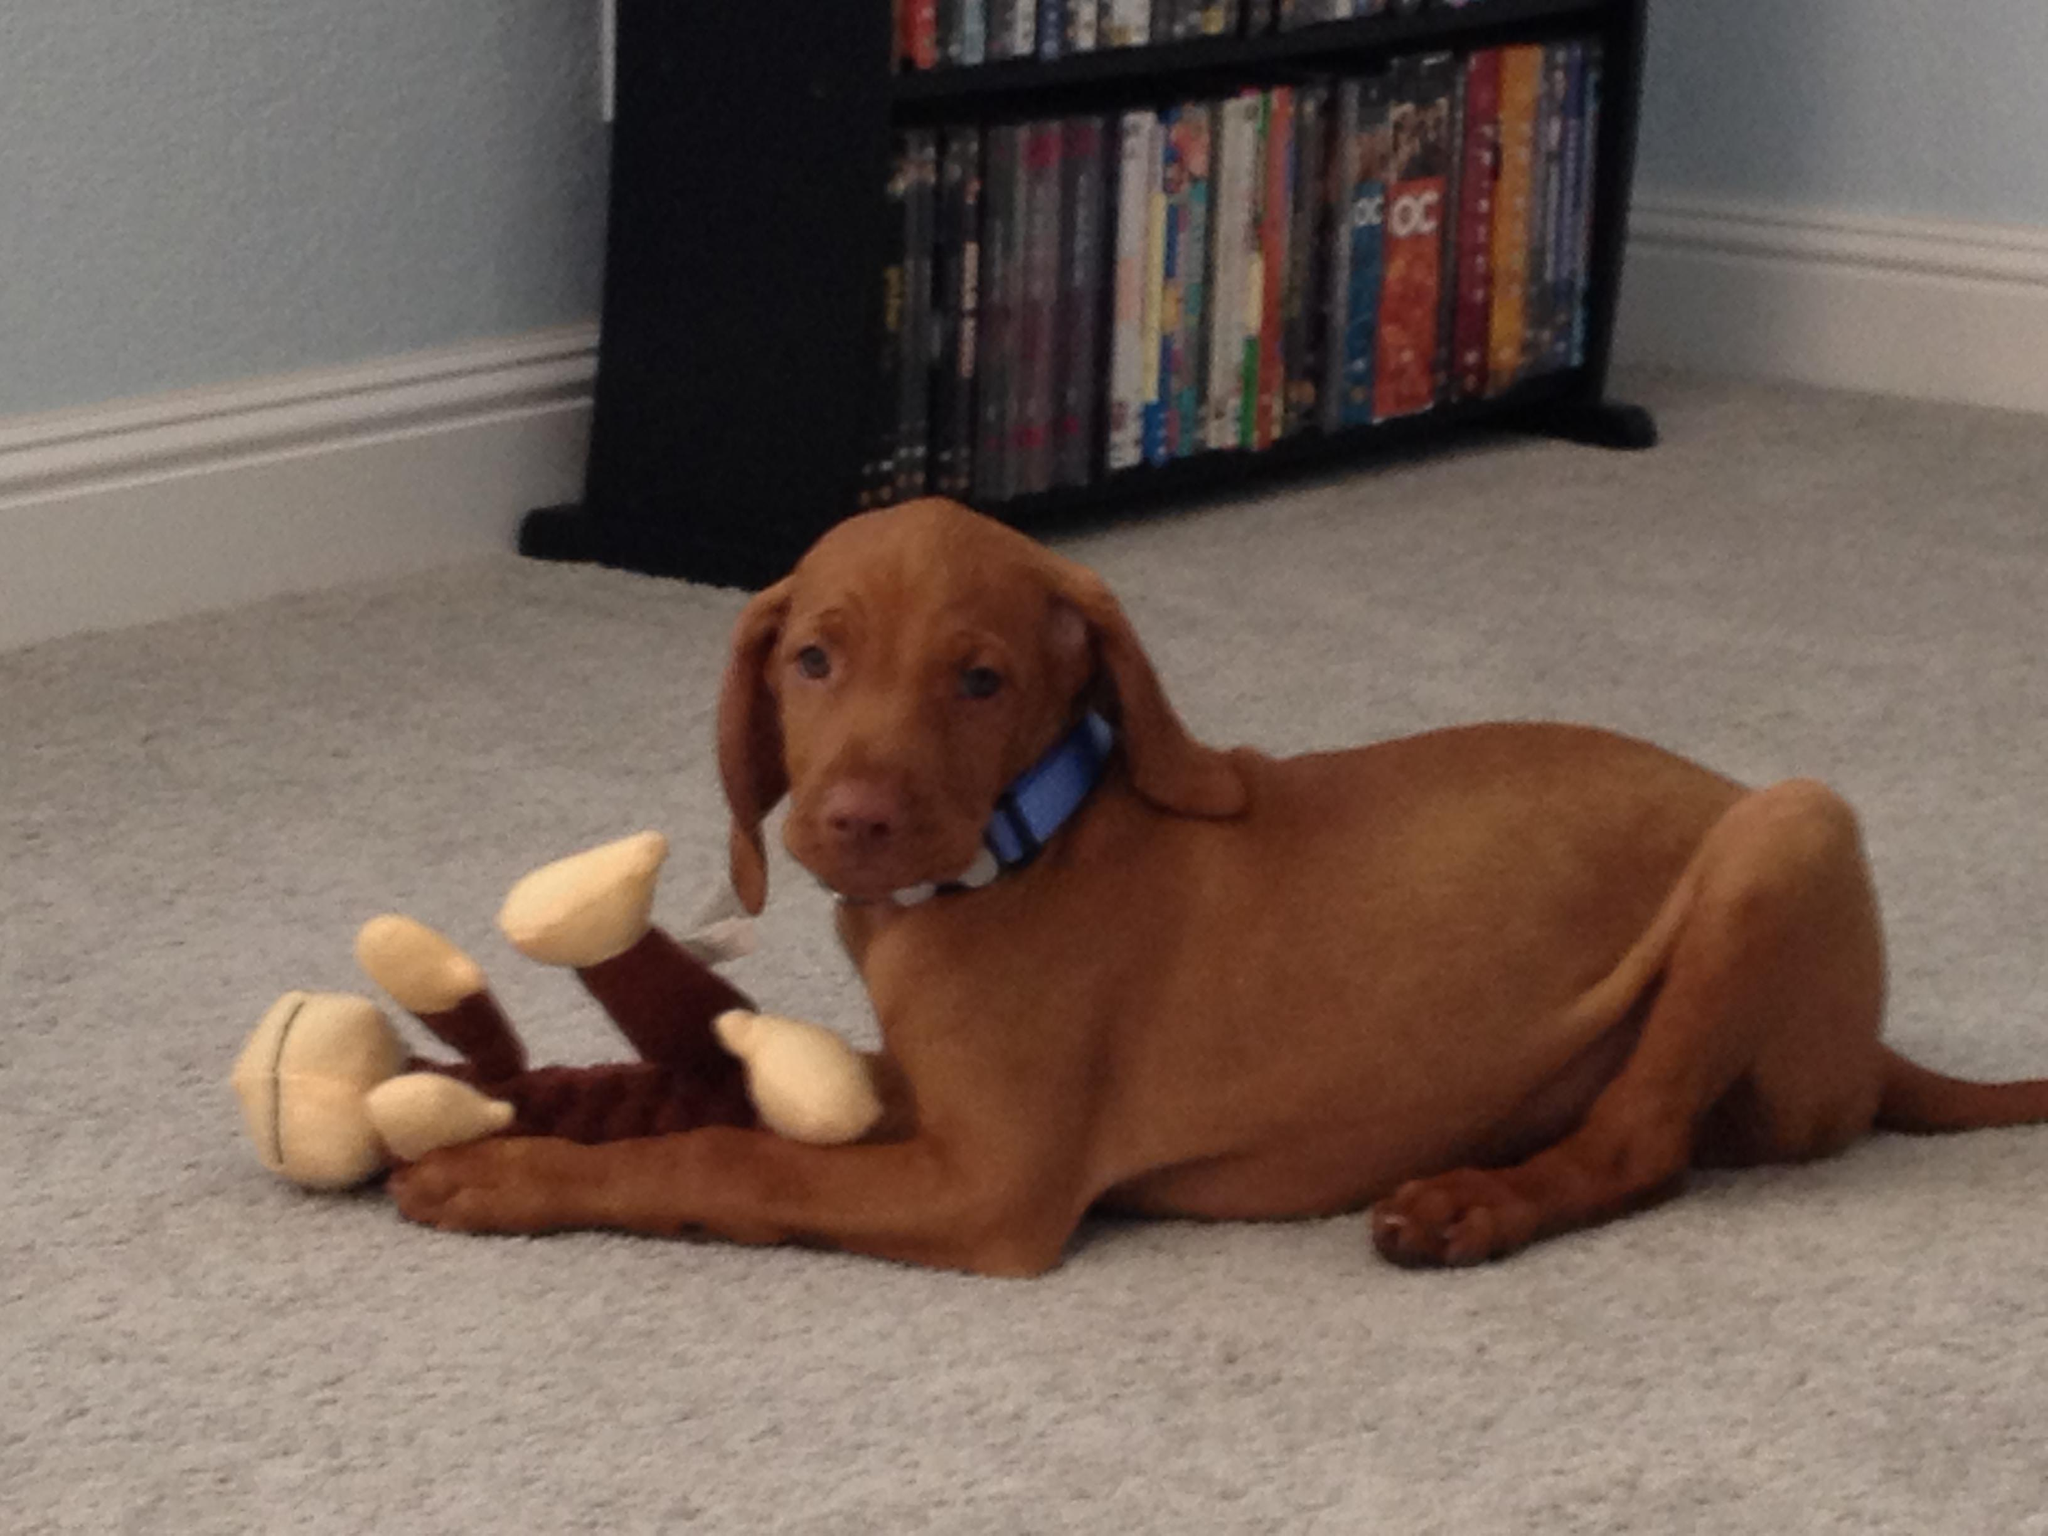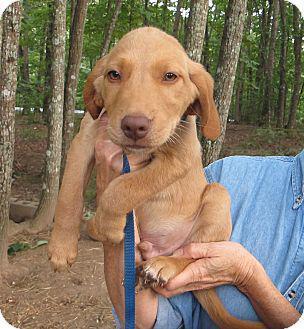The first image is the image on the left, the second image is the image on the right. Analyze the images presented: Is the assertion "Left and right images each contain a red-orange dog sitting upright, turned forward, and wearing a collar - but only one of the dogs pictured has a tag on a ring dangling from its collar." valid? Answer yes or no. No. The first image is the image on the left, the second image is the image on the right. For the images displayed, is the sentence "Two dogs are sitting." factually correct? Answer yes or no. No. 